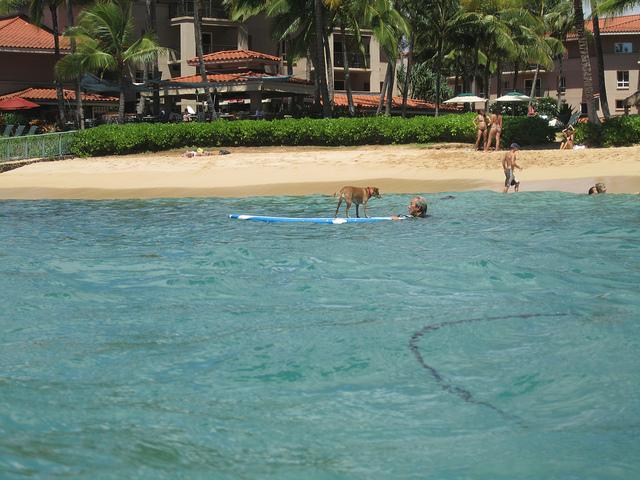What is preventing the dog from being submerged in the water? surfboard 